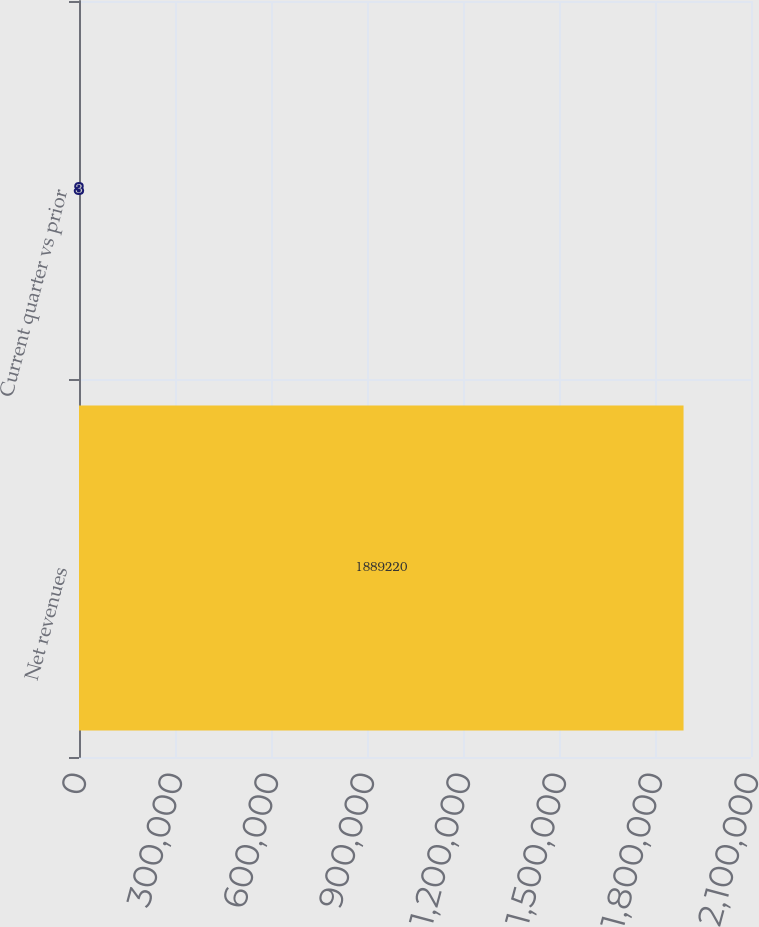<chart> <loc_0><loc_0><loc_500><loc_500><bar_chart><fcel>Net revenues<fcel>Current quarter vs prior<nl><fcel>1.88922e+06<fcel>3<nl></chart> 